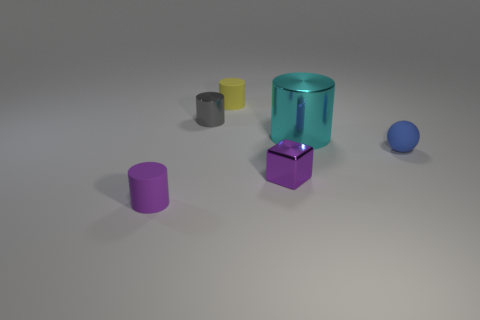Subtract all purple cylinders. How many cylinders are left? 3 Subtract all tiny cylinders. How many cylinders are left? 1 Subtract all brown cylinders. Subtract all cyan spheres. How many cylinders are left? 4 Add 4 large red rubber cylinders. How many objects exist? 10 Subtract all cylinders. How many objects are left? 2 Add 1 purple things. How many purple things exist? 3 Subtract 1 purple cylinders. How many objects are left? 5 Subtract all green rubber balls. Subtract all tiny objects. How many objects are left? 1 Add 4 gray metal things. How many gray metal things are left? 5 